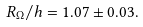Convert formula to latex. <formula><loc_0><loc_0><loc_500><loc_500>R _ { \Omega } / h = 1 . 0 7 \pm 0 . 0 3 .</formula> 